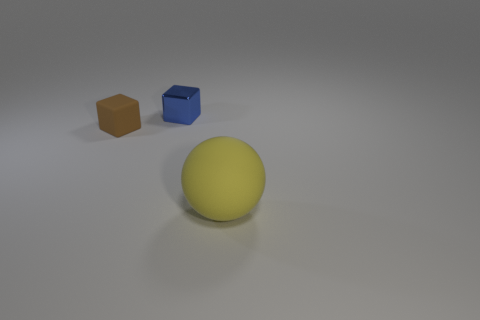How many objects are gray things or rubber things that are to the left of the large sphere?
Your answer should be compact. 1. How many other things are the same shape as the big yellow thing?
Give a very brief answer. 0. Is the material of the small object that is behind the small rubber thing the same as the brown object?
Your response must be concise. No. How many things are either tiny blue things or large yellow balls?
Keep it short and to the point. 2. What is the size of the metallic thing that is the same shape as the small matte thing?
Keep it short and to the point. Small. The blue block has what size?
Provide a short and direct response. Small. Is the number of big yellow things that are left of the small brown matte cube greater than the number of small rubber spheres?
Provide a succinct answer. No. Is there anything else that has the same material as the blue block?
Offer a very short reply. No. There is a matte thing that is on the left side of the large sphere; is it the same color as the small object behind the tiny brown matte block?
Give a very brief answer. No. What is the cube in front of the small cube on the right side of the matte thing that is behind the yellow thing made of?
Your answer should be compact. Rubber. 